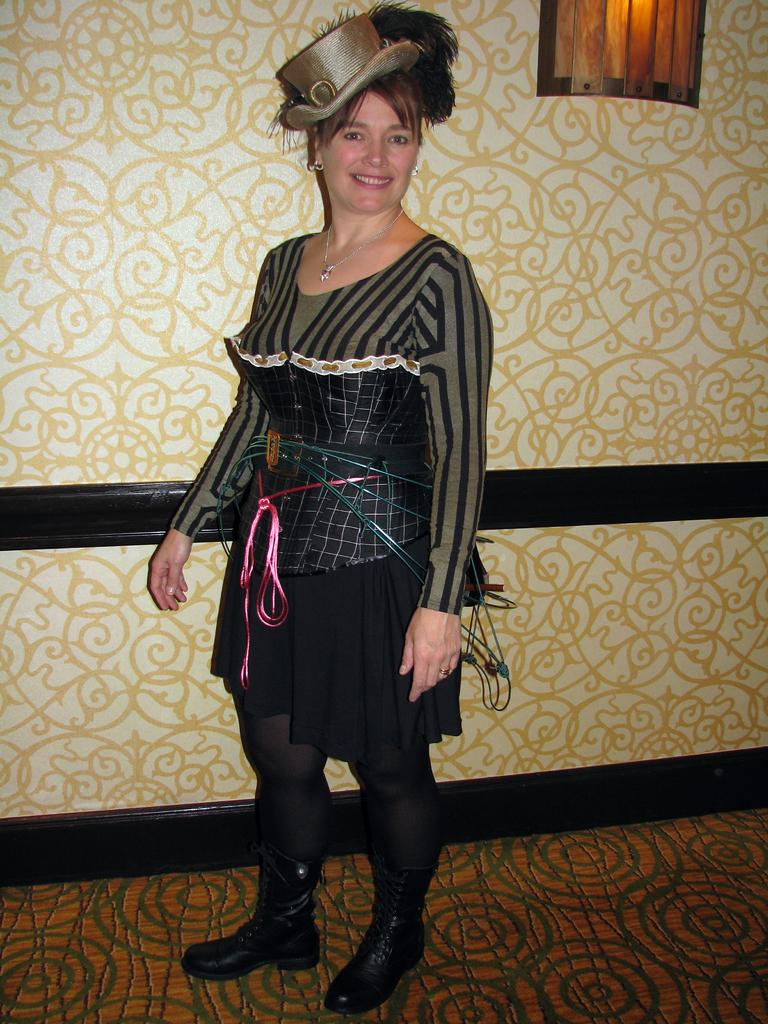Who is present in the image? There is a woman in the image. What is the woman doing in the image? The woman is standing in the image. What is the woman's facial expression in the image? The woman is smiling in the image. What can be seen in the background of the image? There is a wall with a design and a window visible in the background of the image. What type of scarf is the woman wearing in the image? There is no scarf visible in the image; the woman is not wearing one. 